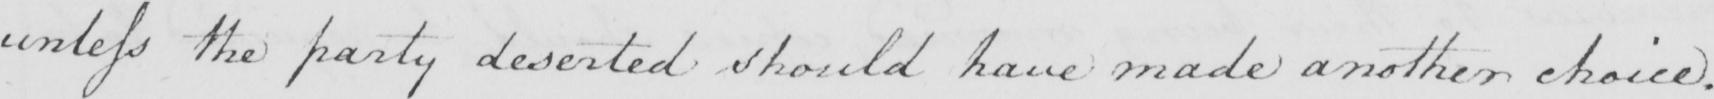What does this handwritten line say? unless the party deserted should have made another choice . 